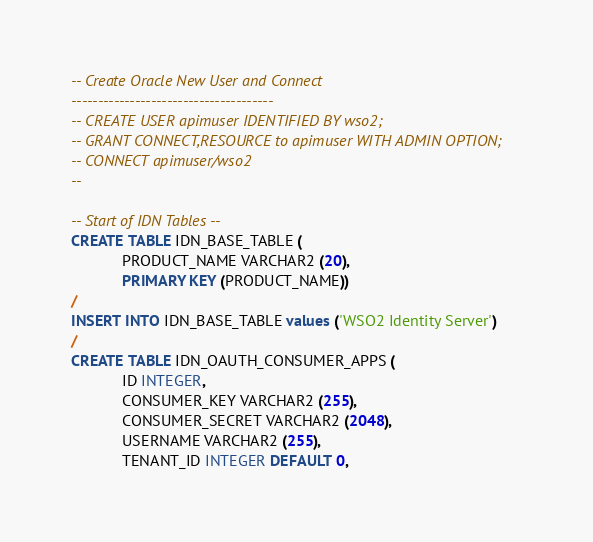<code> <loc_0><loc_0><loc_500><loc_500><_SQL_>-- Create Oracle New User and Connect
--------------------------------------
-- CREATE USER apimuser IDENTIFIED BY wso2;
-- GRANT CONNECT,RESOURCE to apimuser WITH ADMIN OPTION;
-- CONNECT apimuser/wso2
--

-- Start of IDN Tables --
CREATE TABLE IDN_BASE_TABLE (
            PRODUCT_NAME VARCHAR2 (20),
            PRIMARY KEY (PRODUCT_NAME))
/
INSERT INTO IDN_BASE_TABLE values ('WSO2 Identity Server')
/
CREATE TABLE IDN_OAUTH_CONSUMER_APPS (
            ID INTEGER,
            CONSUMER_KEY VARCHAR2 (255),
            CONSUMER_SECRET VARCHAR2 (2048),
            USERNAME VARCHAR2 (255),
            TENANT_ID INTEGER DEFAULT 0,</code> 